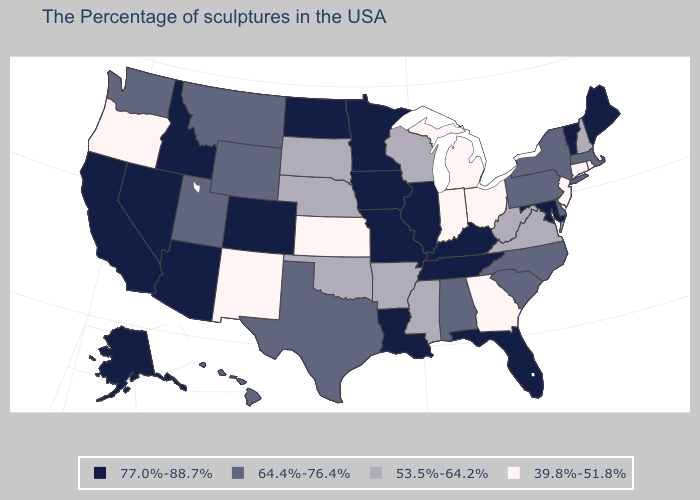Does California have the lowest value in the USA?
Quick response, please. No. Which states have the lowest value in the USA?
Write a very short answer. Rhode Island, Connecticut, New Jersey, Ohio, Georgia, Michigan, Indiana, Kansas, New Mexico, Oregon. What is the lowest value in states that border Montana?
Keep it brief. 53.5%-64.2%. What is the value of Indiana?
Write a very short answer. 39.8%-51.8%. What is the value of Hawaii?
Quick response, please. 64.4%-76.4%. What is the value of Florida?
Give a very brief answer. 77.0%-88.7%. What is the value of Arkansas?
Quick response, please. 53.5%-64.2%. What is the value of North Carolina?
Quick response, please. 64.4%-76.4%. How many symbols are there in the legend?
Answer briefly. 4. Does Iowa have the lowest value in the USA?
Give a very brief answer. No. What is the highest value in the USA?
Quick response, please. 77.0%-88.7%. Does Alaska have the highest value in the USA?
Concise answer only. Yes. Does the first symbol in the legend represent the smallest category?
Concise answer only. No. Which states have the highest value in the USA?
Be succinct. Maine, Vermont, Maryland, Florida, Kentucky, Tennessee, Illinois, Louisiana, Missouri, Minnesota, Iowa, North Dakota, Colorado, Arizona, Idaho, Nevada, California, Alaska. Does California have a lower value than Michigan?
Be succinct. No. 